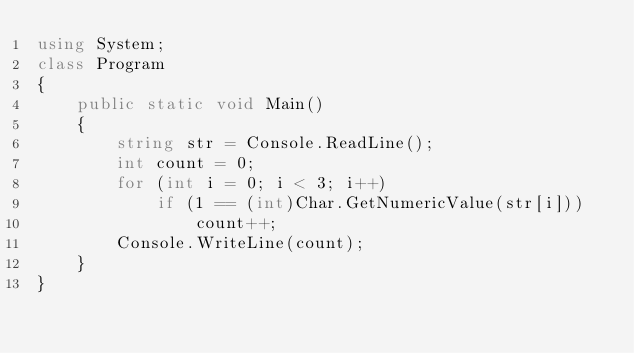Convert code to text. <code><loc_0><loc_0><loc_500><loc_500><_C#_>using System;
class Program
{
    public static void Main()
    {
        string str = Console.ReadLine();
        int count = 0;
        for (int i = 0; i < 3; i++)
            if (1 == (int)Char.GetNumericValue(str[i]))
                count++;
        Console.WriteLine(count);
    }
}</code> 